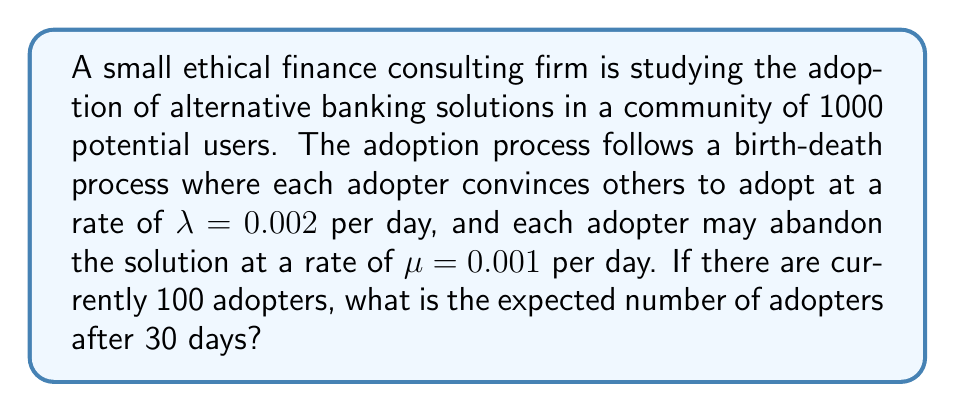Provide a solution to this math problem. To solve this problem, we'll use the birth-death process model:

1. Define the variables:
   $N = 1000$ (total population)
   $X_0 = 100$ (initial number of adopters)
   $\lambda = 0.002$ (adoption rate)
   $\mu = 0.001$ (abandonment rate)
   $t = 30$ (time in days)

2. The expected number of adopters at time $t$ is given by:

   $$E[X_t] = N - (N - X_0)e^{-(\lambda + \mu)t} + \frac{\mu N}{\lambda + \mu}(1 - e^{-(\lambda + \mu)t})$$

3. Substitute the values:

   $$E[X_{30}] = 1000 - (1000 - 100)e^{-(0.002 + 0.001)30} + \frac{0.001 \cdot 1000}{0.002 + 0.001}(1 - e^{-(0.002 + 0.001)30})$$

4. Simplify:

   $$E[X_{30}] = 1000 - 900e^{-0.09} + \frac{1000}{3}(1 - e^{-0.09})$$

5. Calculate:

   $$E[X_{30}] = 1000 - 900 \cdot 0.9139 + 333.33 \cdot 0.0861$$

   $$E[X_{30}] = 1000 - 822.51 + 28.70$$

   $$E[X_{30}] = 206.19$$

6. Round to the nearest whole number:

   $$E[X_{30}] \approx 206$$
Answer: 206 adopters 